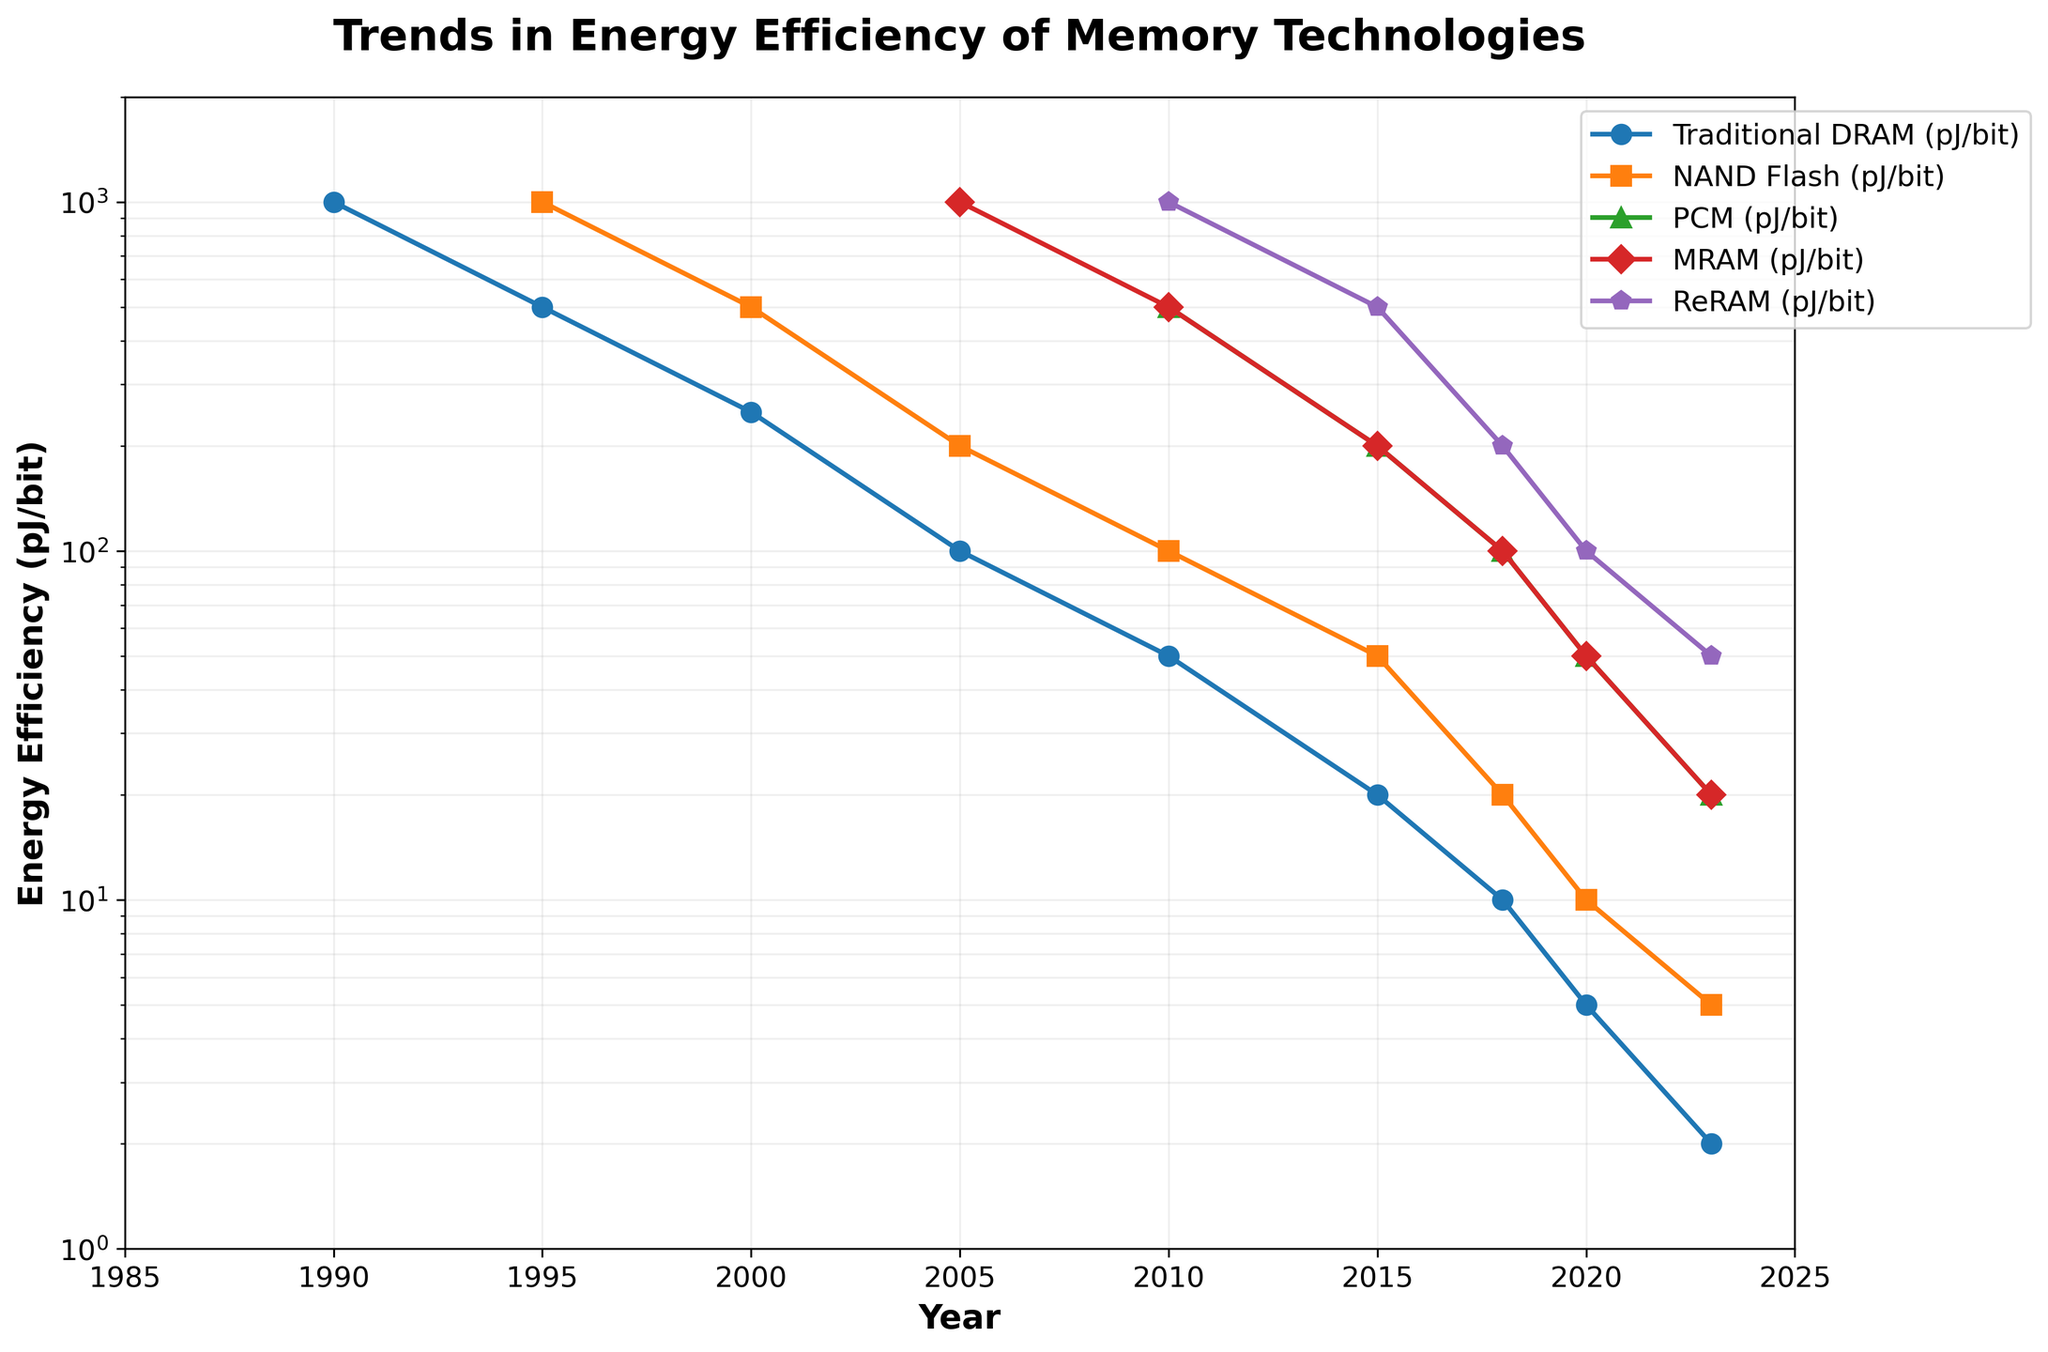What memory technology had the lowest energy efficiency in 1990 and what was its value? By looking at the 1990 data points in the figure, we can see that Traditional DRAM is the only technology with data, and its value is 1000 pJ/bit.
Answer: Traditional DRAM, 1000 pJ/bit Between 2010 and 2023, which memory technology showed the most significant improvement in energy efficiency? By comparing the values of each technology in 2010 and 2023, we observe the following reductions: Traditional DRAM (50 to 2 pJ/bit), NAND Flash (100 to 5 pJ/bit), PCM (500 to 20 pJ/bit), MRAM (500 to 20 pJ/bit), and ReRAM (1000 to 50 pJ/bit). The highest reduction is seen in Traditional DRAM with a drop from 50 to 2 pJ/bit.
Answer: Traditional DRAM Which memory technology had an energy efficiency of 20 pJ/bit in the year 2023? By observing the values for 2023, both PCM and MRAM show an energy efficiency value of 20 pJ/bit.
Answer: PCM and MRAM When did NAND Flash first show a lower energy efficiency value than Traditional DRAM? By examining the plot, NAND Flash shows a lower value than Traditional DRAM starting in 2005, where NAND Flash is at 200 pJ/bit and Traditional DRAM is at 100 pJ/bit.
Answer: 2005 What is the difference in energy efficiency improvements between NAND Flash and ReRAM from 2010 to 2023? NAND Flash improves from 100 pJ/bit in 2010 to 5 pJ/bit in 2023, which is a difference of 95 pJ/bit. ReRAM improves from 1000 pJ/bit in 2010 to 50 pJ/bit in 2023, which is a difference of 950 pJ/bit. The calculation shows that ReRAM had a higher improvement by 950 - 95 = 855 pJ/bit.
Answer: 855 pJ/bit In what year did PCM reach the same energy efficiency level as NAND Flash? By analyzing the plot, PCM and NAND Flash both reached 50 pJ/bit in 2020.
Answer: 2020 What is the average energy efficiency of MRAM over the years where its data points exist (2005-2023)? MRAM has data points in years 2005 (1000 pJ/bit), 2010 (500 pJ/bit), 2015 (200 pJ/bit), 2018 (100 pJ/bit), 2020 (50 pJ/bit), and 2023 (20 pJ/bit). Summing these and dividing by the number of data points gives (1000 + 500 + 200 + 100 + 50 + 20) / 6 = 1870 / 6 ≈ 311.67 pJ/bit.
Answer: 311.67 pJ/bit Which technology had the greatest energy efficiency in 2023, and what was its value? In 2023, the plotted values show that Traditional DRAM has the lowest value among all technologies at 2 pJ/bit, making it the one with the greatest energy efficiency.
Answer: Traditional DRAM, 2 pJ/bit 